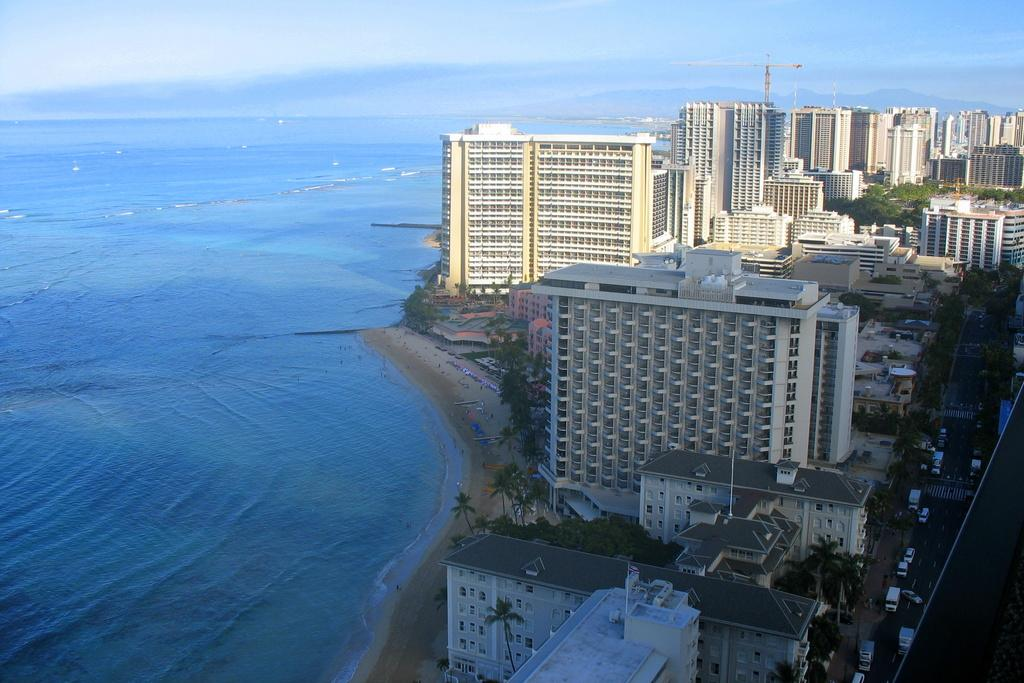What type of structures can be seen in the image? There are many buildings in the image. What other natural elements are present in the image? There are trees in the image. Are there any man-made objects visible besides buildings? Yes, there are vehicles in the image. What can be seen in the background of the image? The sky with clouds is visible in the background of the image. Is there any water visible in the image? Yes, there is water visible in the image. Reasoning: Let's think step by following the guidelines to produce the conversation. We start by identifying the main subjects and objects in the image based on the provided facts. We then formulate questions that focus on the location and characteristics of these subjects and objects, ensuring that each question can be answered definitively with the information given. We avoid yes/no questions and ensure that the language is simple and clear. Absurd Question/Answer: How many dimes can be seen on the collar of the dog in the image? There is no dog or collar present in the image; it features buildings, trees, vehicles, water, and a sky with clouds. How many dimes can be seen on the collar of the dog in the image? There is no dog or collar present in the image; it features buildings, trees, vehicles, water, and a sky with clouds. 